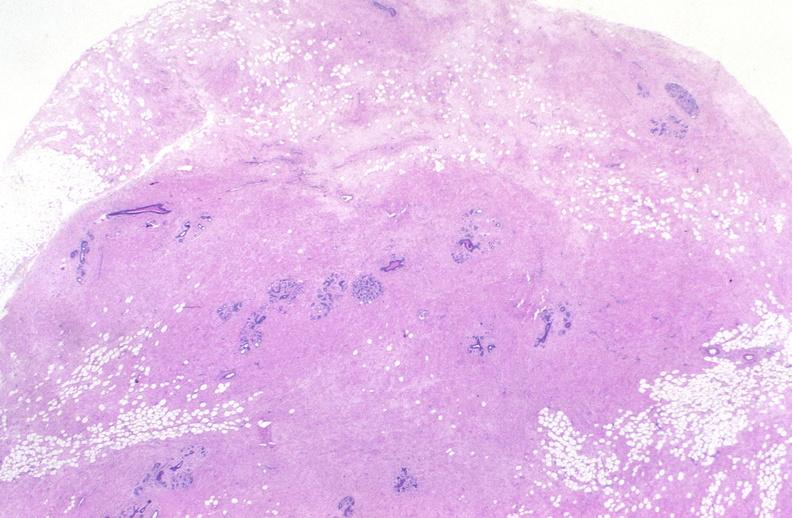what does this image show?
Answer the question using a single word or phrase. Breast 